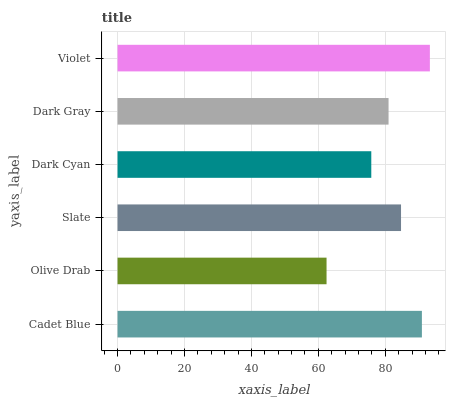Is Olive Drab the minimum?
Answer yes or no. Yes. Is Violet the maximum?
Answer yes or no. Yes. Is Slate the minimum?
Answer yes or no. No. Is Slate the maximum?
Answer yes or no. No. Is Slate greater than Olive Drab?
Answer yes or no. Yes. Is Olive Drab less than Slate?
Answer yes or no. Yes. Is Olive Drab greater than Slate?
Answer yes or no. No. Is Slate less than Olive Drab?
Answer yes or no. No. Is Slate the high median?
Answer yes or no. Yes. Is Dark Gray the low median?
Answer yes or no. Yes. Is Cadet Blue the high median?
Answer yes or no. No. Is Olive Drab the low median?
Answer yes or no. No. 